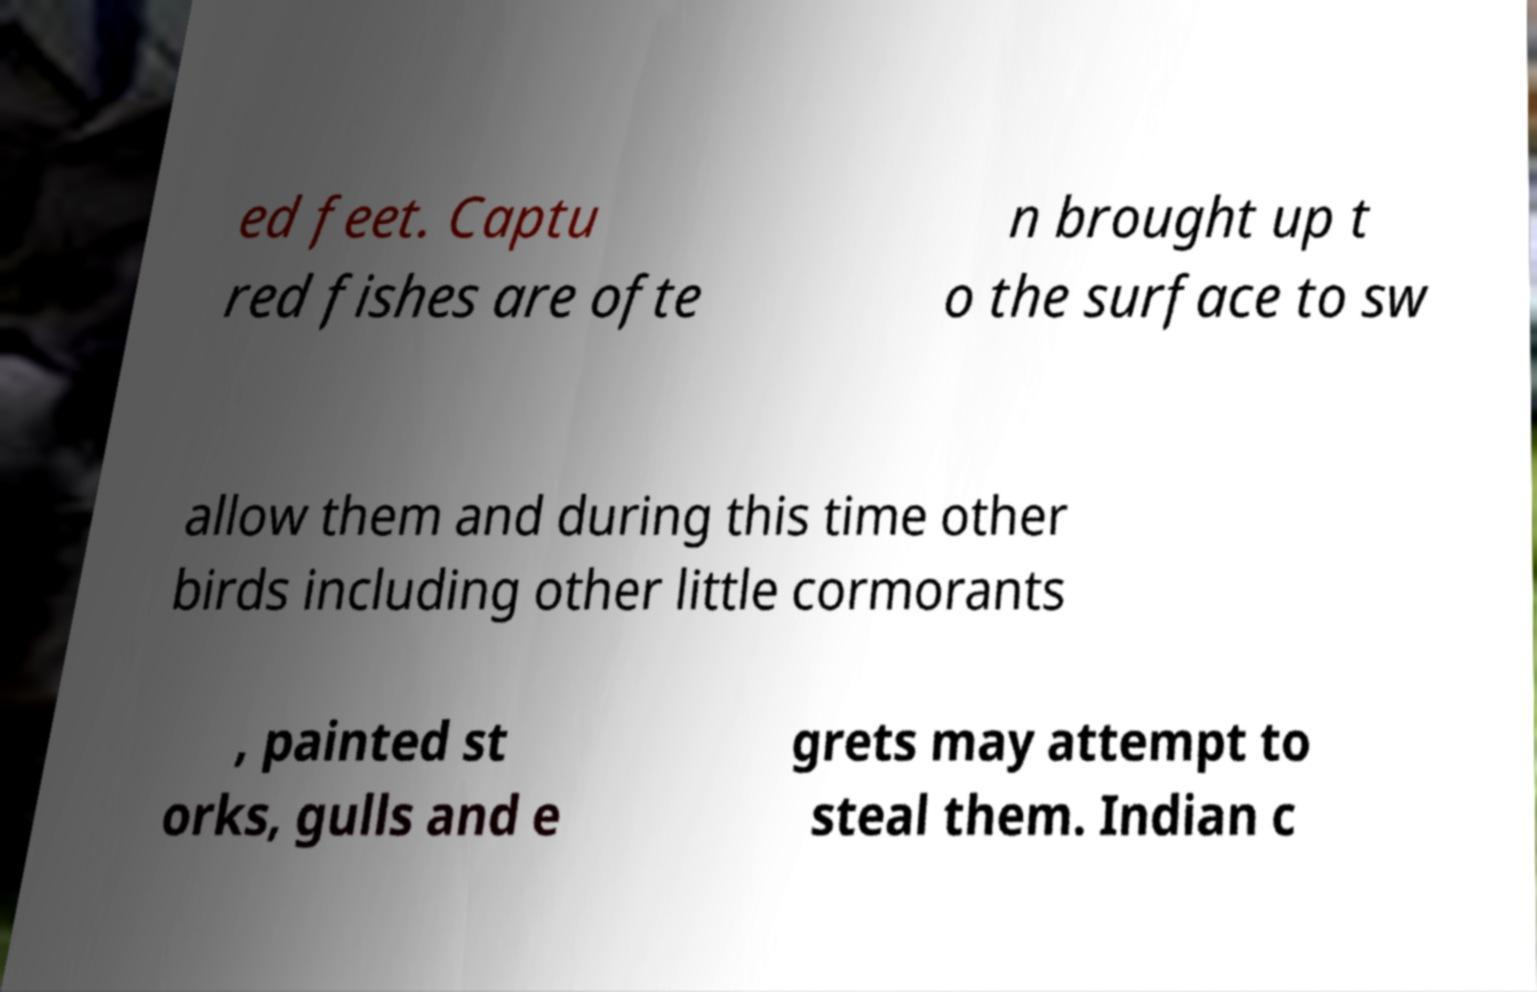What messages or text are displayed in this image? I need them in a readable, typed format. ed feet. Captu red fishes are ofte n brought up t o the surface to sw allow them and during this time other birds including other little cormorants , painted st orks, gulls and e grets may attempt to steal them. Indian c 